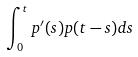Convert formula to latex. <formula><loc_0><loc_0><loc_500><loc_500>\int _ { 0 } ^ { t } p ^ { \prime } ( s ) p ( t - s ) d s</formula> 